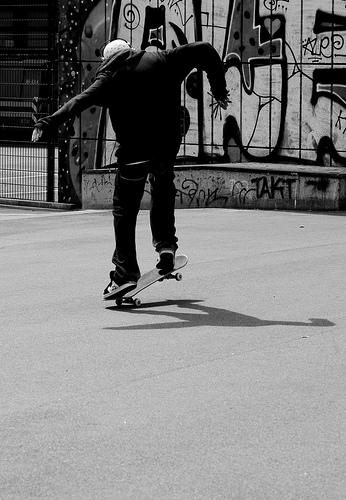Question: when was this photo taken?
Choices:
A. Nighttime.
B. Winter.
C. During the day.
D. Spring.
Answer with the letter. Answer: C Question: why is there a shadow?
Choices:
A. It's afternoon.
B. The sun's out.
C. The sun is shining on the man.
D. From the building.
Answer with the letter. Answer: C Question: who was the subject of the photo?
Choices:
A. The woman.
B. The dog.
C. The bear.
D. The man.
Answer with the letter. Answer: D 